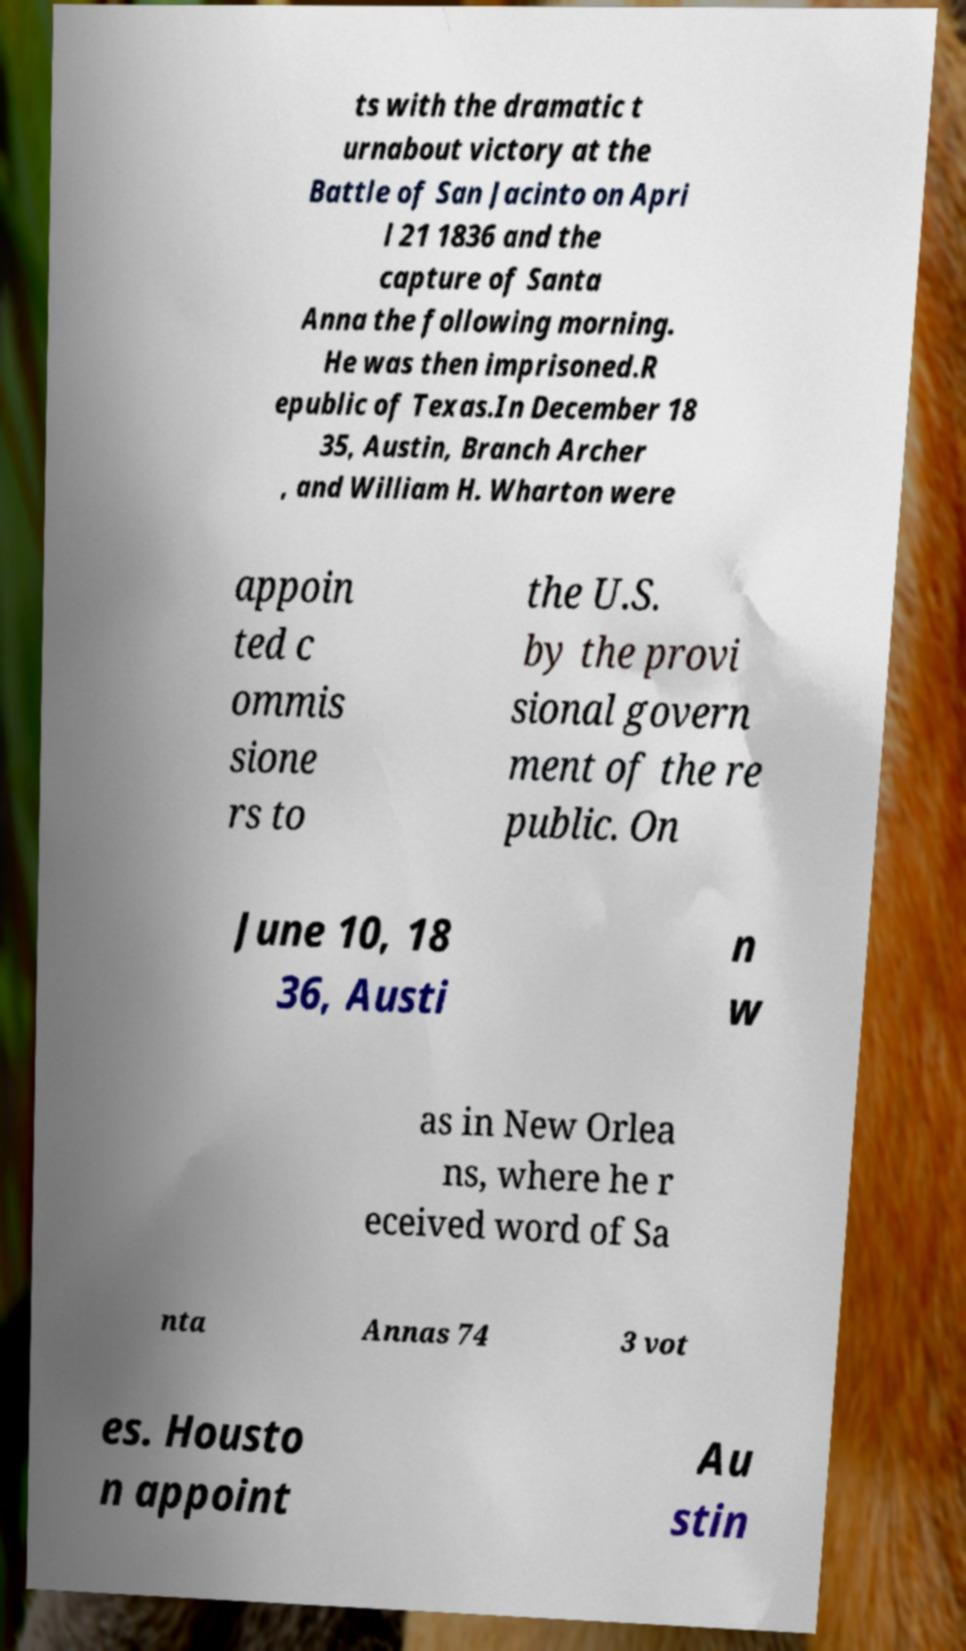Please read and relay the text visible in this image. What does it say? ts with the dramatic t urnabout victory at the Battle of San Jacinto on Apri l 21 1836 and the capture of Santa Anna the following morning. He was then imprisoned.R epublic of Texas.In December 18 35, Austin, Branch Archer , and William H. Wharton were appoin ted c ommis sione rs to the U.S. by the provi sional govern ment of the re public. On June 10, 18 36, Austi n w as in New Orlea ns, where he r eceived word of Sa nta Annas 74 3 vot es. Housto n appoint Au stin 